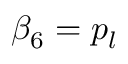Convert formula to latex. <formula><loc_0><loc_0><loc_500><loc_500>\beta _ { 6 } = p _ { l }</formula> 